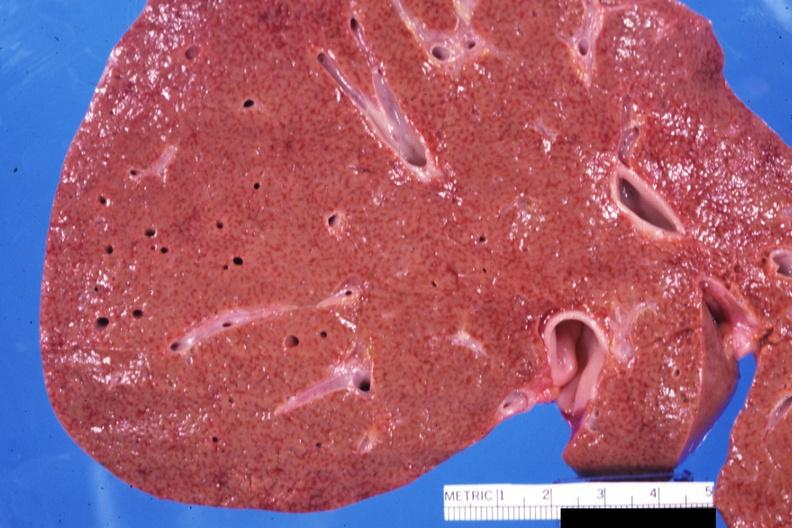s liver present?
Answer the question using a single word or phrase. Yes 